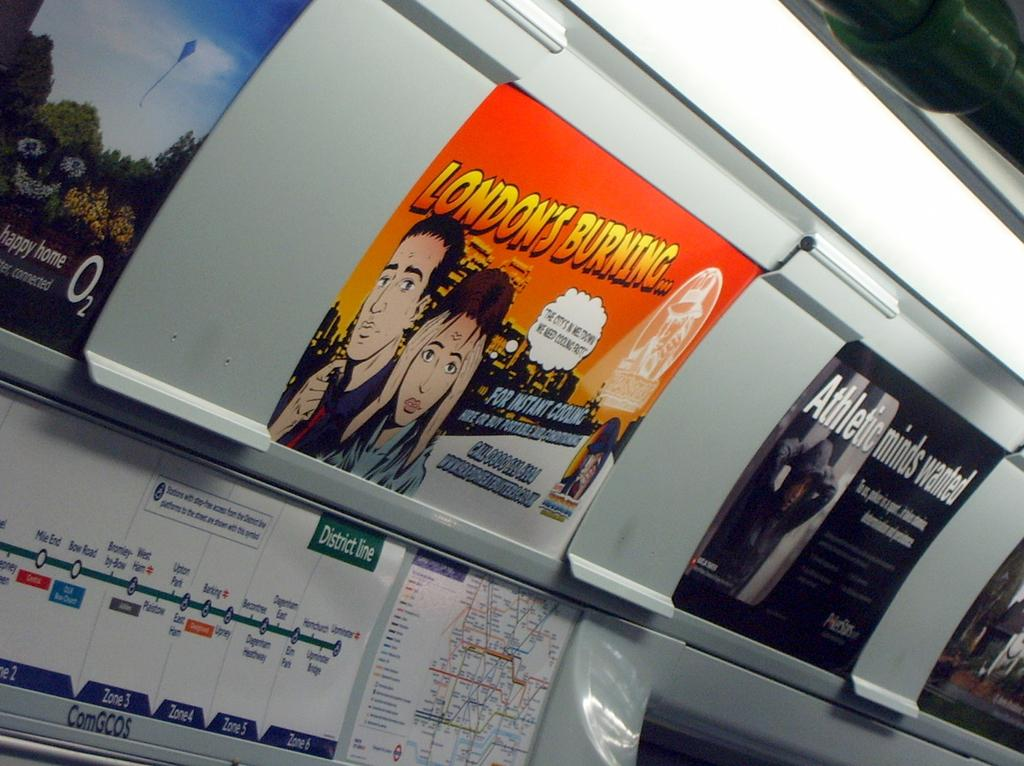<image>
Summarize the visual content of the image. An advertisement detailing London being burned is placed on a wall. 